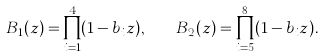Convert formula to latex. <formula><loc_0><loc_0><loc_500><loc_500>B _ { 1 } ( z ) = \prod _ { i = 1 } ^ { 4 } ( 1 - b _ { i } z ) , \quad B _ { 2 } ( z ) = \prod _ { i = 5 } ^ { 8 } ( 1 - b _ { i } z ) .</formula> 